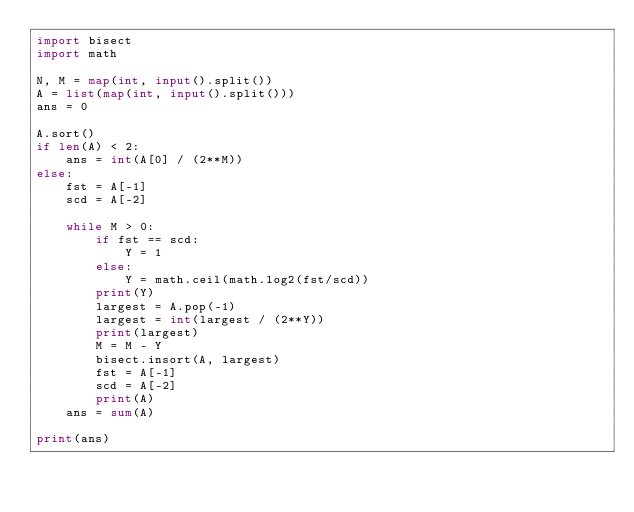<code> <loc_0><loc_0><loc_500><loc_500><_Python_>import bisect
import math

N, M = map(int, input().split())
A = list(map(int, input().split()))
ans = 0

A.sort()
if len(A) < 2:
    ans = int(A[0] / (2**M))
else:
    fst = A[-1]
    scd = A[-2]

    while M > 0:
        if fst == scd:
            Y = 1
        else:
            Y = math.ceil(math.log2(fst/scd))
        print(Y)
        largest = A.pop(-1)
        largest = int(largest / (2**Y))
        print(largest)
        M = M - Y
        bisect.insort(A, largest)
        fst = A[-1]
        scd = A[-2]
        print(A)
    ans = sum(A)

print(ans)</code> 